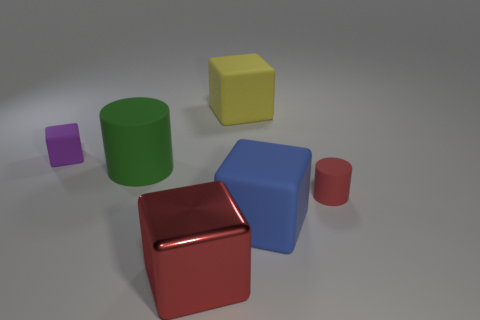Add 2 small cyan cubes. How many objects exist? 8 Subtract all cylinders. How many objects are left? 4 Subtract all tiny purple matte cylinders. Subtract all tiny rubber things. How many objects are left? 4 Add 4 small red cylinders. How many small red cylinders are left? 5 Add 3 large gray objects. How many large gray objects exist? 3 Subtract 1 blue blocks. How many objects are left? 5 